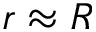Convert formula to latex. <formula><loc_0><loc_0><loc_500><loc_500>r \approx R</formula> 